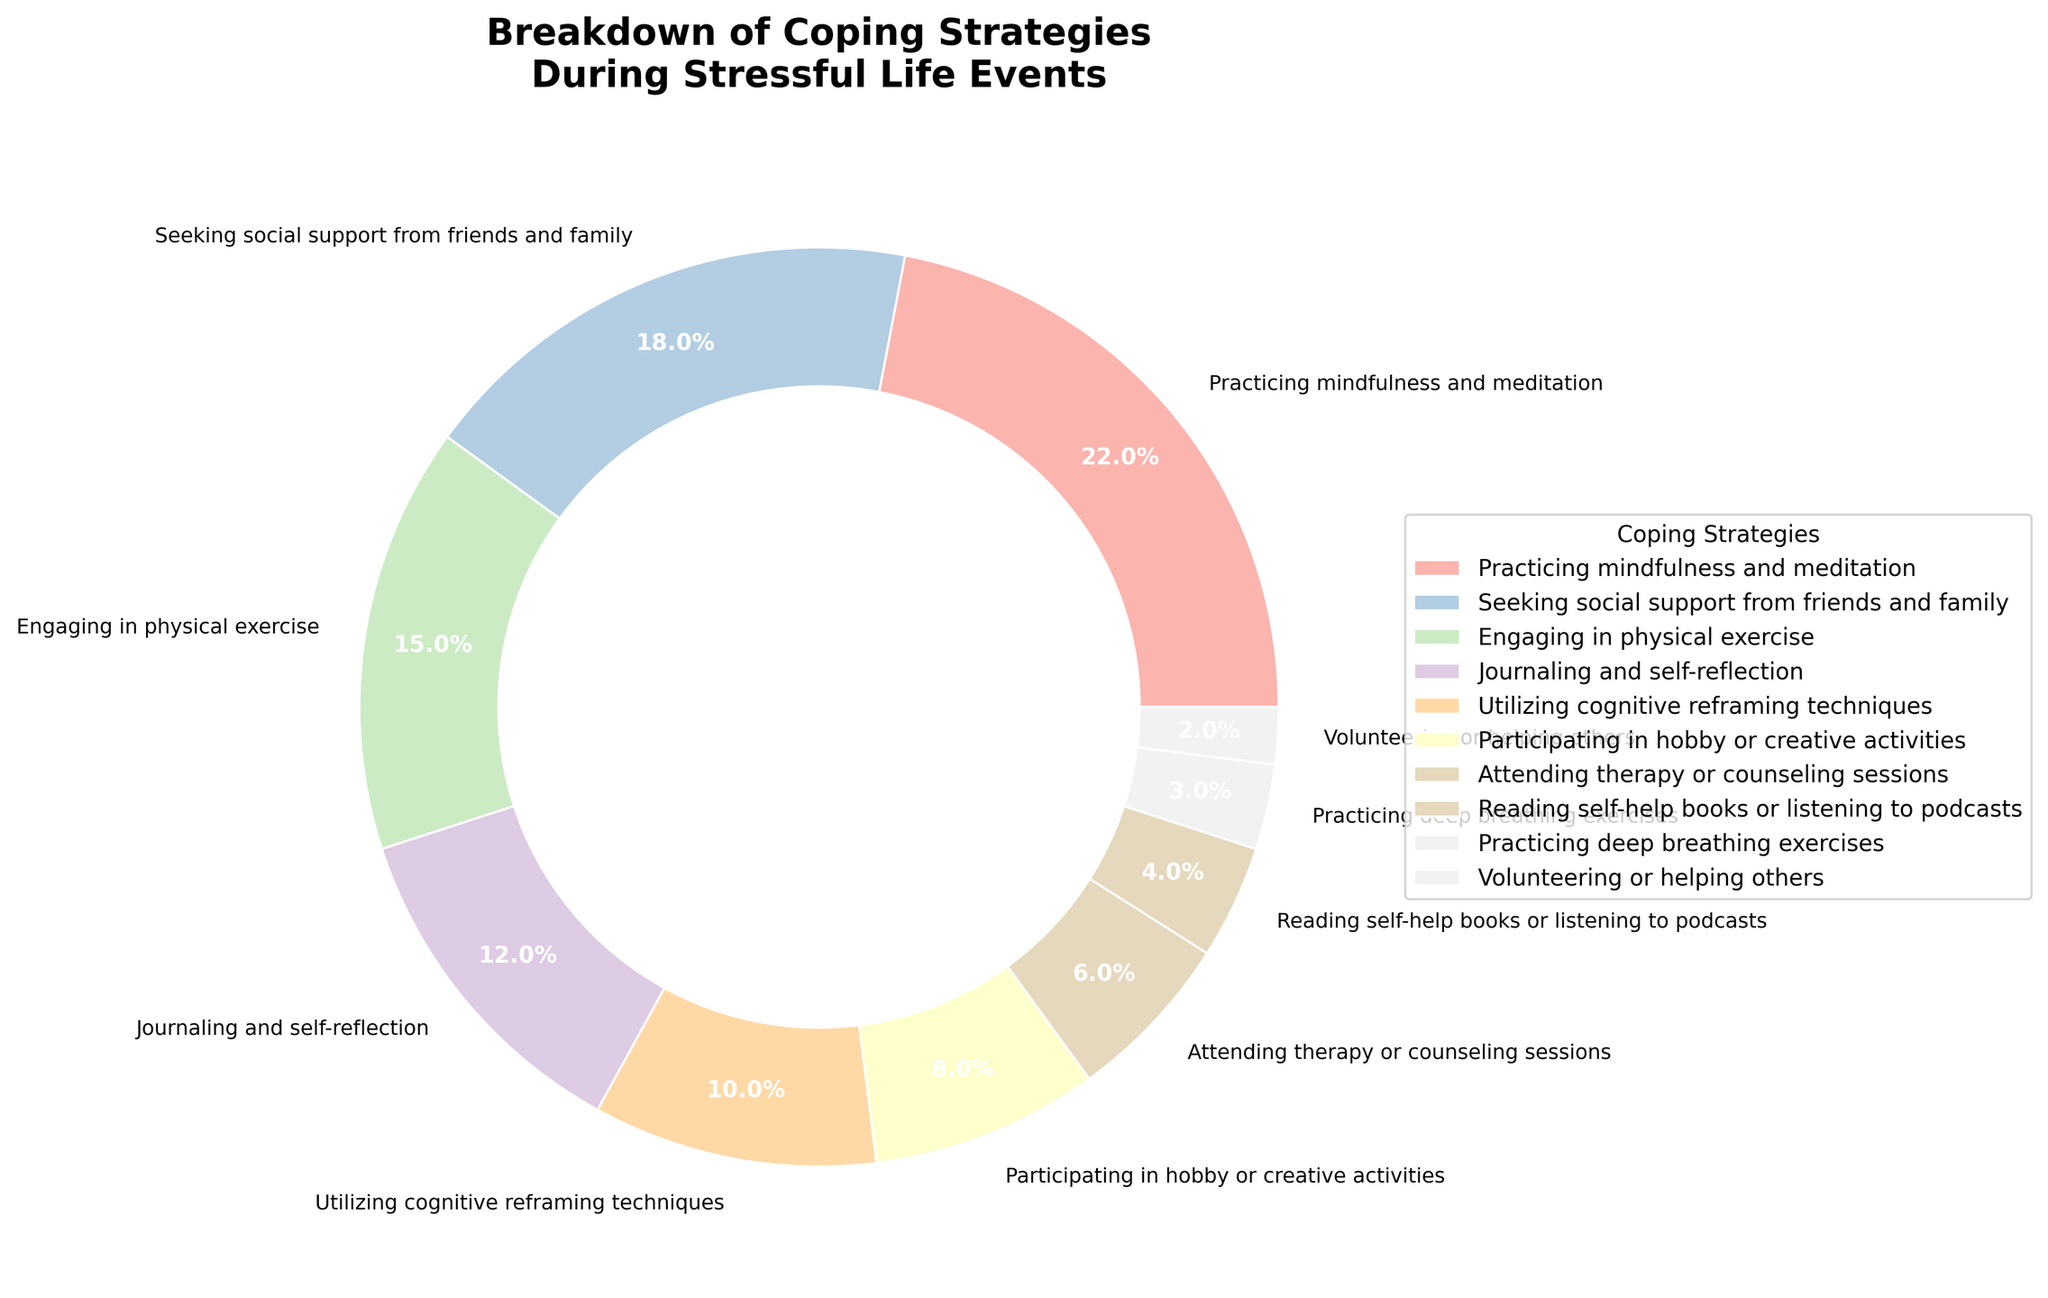Which coping strategy is used the most during stressful life events? The figure shows that "Practicing mindfulness and meditation" occupies the largest segment of the pie chart.
Answer: Practicing mindfulness and meditation Which coping strategy is used less often: "Engaging in physical exercise" or "Attending therapy or counseling sessions"? Comparing the two segments, "Engaging in physical exercise" takes up 15% while "Attending therapy or counseling sessions" takes up 6%, making the former more frequently used.
Answer: Attending therapy or counseling sessions What is the total percentage of people using "Practicing mindfulness and meditation" and "Seeking social support from friends and family"? Adding the percentages of these two strategies: 22% (mindfulness and meditation) + 18% (social support) = 40%.
Answer: 40% How much more popular is "Journaling and self-reflection" compared to "Volunteering or helping others"? Subtracting the percentage of "Volunteering or helping others" from "Journaling and self-reflection": 12% - 2% = 10%.
Answer: 10% Which coping strategies together sum up to 25%? "Participating in hobby or creative activities" (8%) + "Attending therapy or counseling sessions" (6%) + "Reading self-help books or listening to podcasts" (4%) + "Practicing deep breathing exercises" (3%) + "Volunteering or helping others" (2%) together make up 23%. Adding "Utilizing cognitive reframing techniques" (10%) brings it over 25%. Hence, "Journaling and self-reflection" (12%) plus a combination from above can reach around 25%.
Answer: Various combinations including "Journaling and self-reflection" What coping strategy has a percentage closest to 10% and what is it? The figure shows that "Utilizing cognitive reframing techniques" is exactly 10%.
Answer: Utilizing cognitive reframing techniques How does the percentage of "Reading self-help books or listening to podcasts" compare with "Practicing deep breathing exercises"? "Reading self-help books or listening to podcasts" is at 4% while "Practicing deep breathing exercises" is at 3%, indicating the former is slightly higher.
Answer: Reading self-help books or listening to podcasts What is the least utilized coping strategy during stressful life events? The smallest segment of the pie chart represents "Volunteering or helping others" at 2%.
Answer: Volunteering or helping others 